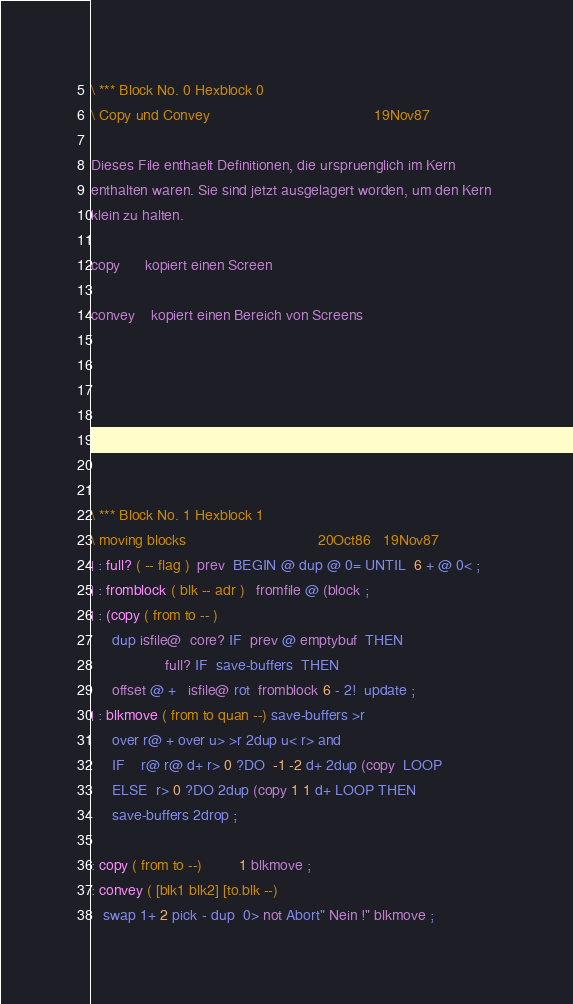<code> <loc_0><loc_0><loc_500><loc_500><_Forth_>\ *** Block No. 0 Hexblock 0 
\ Copy und Convey                                        19Nov87
                                                                
Dieses File enthaelt Definitionen, die urspruenglich im Kern    
enthalten waren. Sie sind jetzt ausgelagert worden, um den Kern 
klein zu halten.                                                
                                                                
copy      kopiert einen Screen                                  
                                                                
convey    kopiert einen Bereich von Screens                     
                                                                
                                                                
                                                                
                                                                
                                                                
                                                                
                                                                
\ *** Block No. 1 Hexblock 1 
\ moving blocks                                20Oct86   19Nov87
| : full? ( -- flag )  prev  BEGIN @ dup @ 0= UNTIL  6 + @ 0< ; 
| : fromblock ( blk -- adr )   fromfile @ (block ;              
| : (copy ( from to -- )                                        
     dup isfile@  core? IF  prev @ emptybuf  THEN               
                  full? IF  save-buffers  THEN                  
     offset @ +   isfile@ rot  fromblock 6 - 2!  update ;       
| : blkmove ( from to quan --) save-buffers >r                  
     over r@ + over u> >r 2dup u< r> and                        
     IF    r@ r@ d+ r> 0 ?DO  -1 -2 d+ 2dup (copy  LOOP         
     ELSE  r> 0 ?DO 2dup (copy 1 1 d+ LOOP THEN                 
     save-buffers 2drop ;                                       
                                                                
: copy ( from to --)         1 blkmove ;                        
: convey ( [blk1 blk2] [to.blk --)                              
   swap 1+ 2 pick - dup  0> not Abort" Nein !" blkmove ;        
</code> 